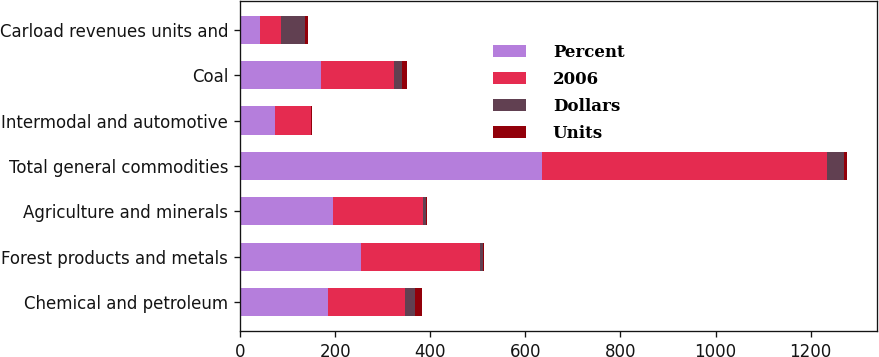<chart> <loc_0><loc_0><loc_500><loc_500><stacked_bar_chart><ecel><fcel>Chemical and petroleum<fcel>Forest products and metals<fcel>Agriculture and minerals<fcel>Total general commodities<fcel>Intermodal and automotive<fcel>Coal<fcel>Carload revenues units and<nl><fcel>Percent<fcel>184.4<fcel>255.3<fcel>195.4<fcel>635.1<fcel>74.1<fcel>170.3<fcel>43.05<nl><fcel>2006<fcel>162<fcel>248.4<fcel>189.4<fcel>599.8<fcel>74.8<fcel>154.1<fcel>43.05<nl><fcel>Dollars<fcel>22.4<fcel>6.9<fcel>6<fcel>35.3<fcel>0.7<fcel>16.2<fcel>50.8<nl><fcel>Units<fcel>14<fcel>3<fcel>3<fcel>6<fcel>1<fcel>11<fcel>6<nl></chart> 